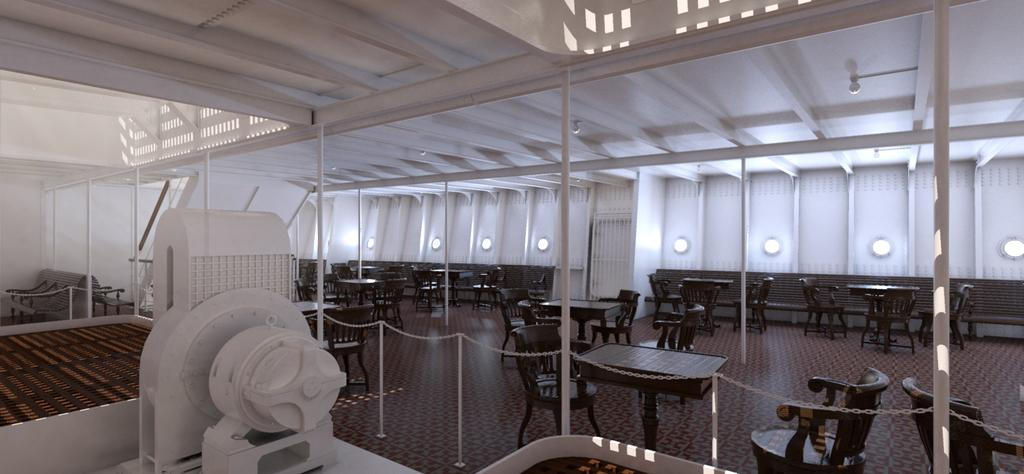What type of furniture is present in the image? There are chairs and tables in the image. Can you describe the machine located on the left side of the image? There is a machine on the left side of the image. How many men are playing a game on the dock in the image? There is no dock, men, or game present in the image. What type of creature is shown interacting with the machine on the left side of the image? There is no creature shown interacting with the machine on the left side of the image; only the machine is present. 